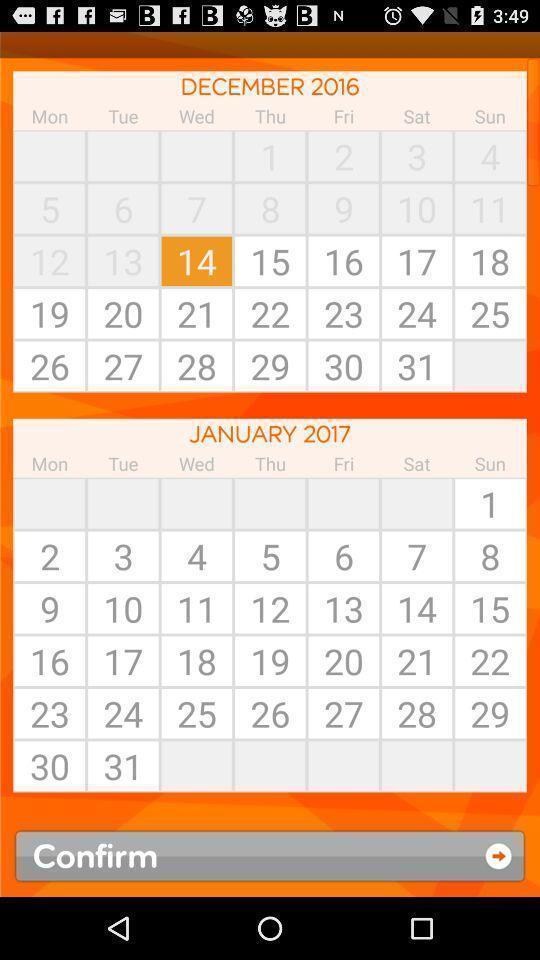Describe the key features of this screenshot. Page for selecting day for booking flight. 